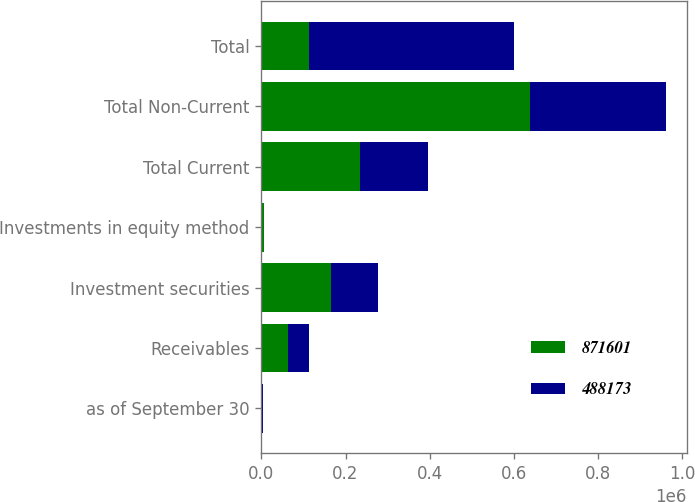Convert chart to OTSL. <chart><loc_0><loc_0><loc_500><loc_500><stacked_bar_chart><ecel><fcel>as of September 30<fcel>Receivables<fcel>Investment securities<fcel>Investments in equity method<fcel>Total Current<fcel>Total Non-Current<fcel>Total<nl><fcel>871601<fcel>2010<fcel>63813<fcel>164994<fcel>5401<fcel>234208<fcel>637393<fcel>112853<nl><fcel>488173<fcel>2009<fcel>50088<fcel>112853<fcel>0<fcel>162941<fcel>325232<fcel>488173<nl></chart> 